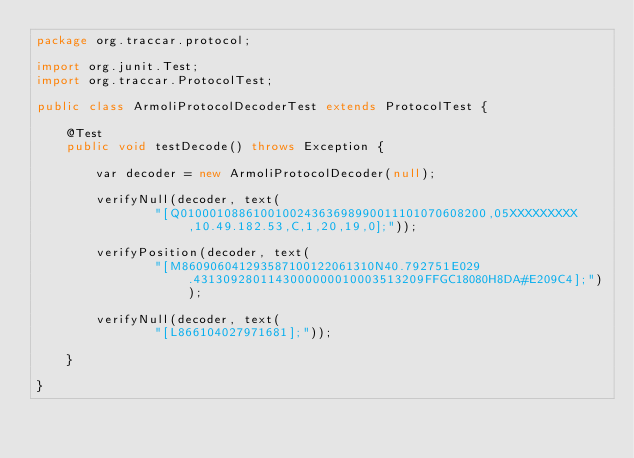<code> <loc_0><loc_0><loc_500><loc_500><_Java_>package org.traccar.protocol;

import org.junit.Test;
import org.traccar.ProtocolTest;

public class ArmoliProtocolDecoderTest extends ProtocolTest {

    @Test
    public void testDecode() throws Exception {

        var decoder = new ArmoliProtocolDecoder(null);

        verifyNull(decoder, text(
                "[Q010001088610010024363698990011101070608200,05XXXXXXXXX,10.49.182.53,C,1,20,19,0];"));

        verifyPosition(decoder, text(
                "[M860906041293587100122061310N40.792751E029.4313092801143000000010003513209FFGC18080H8DA#E209C4];"));

        verifyNull(decoder, text(
                "[L866104027971681];"));

    }

}
</code> 